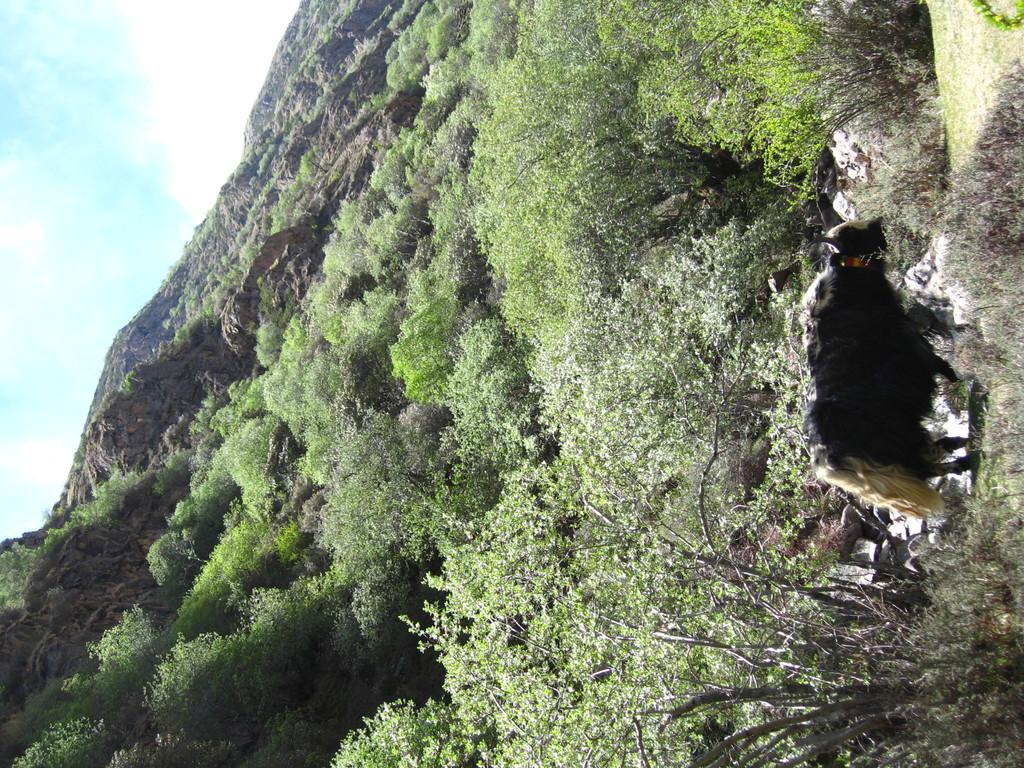What type of animal can be seen in the image? There is an animal in the image, but its specific type cannot be determined from the provided facts. Where is the animal located in the image? The animal is on grassland in the image. What other natural elements can be seen in the grassland? There are plants and trees in the grassland. What is visible in the background of the image? There is a hill in the background of the image, and it has trees on it. What part of the sky is visible in the image? The sky is visible at the top left of the image. How many baskets are being used for the animal's growth in the image? There is no mention of baskets or the animal's growth in the image. 